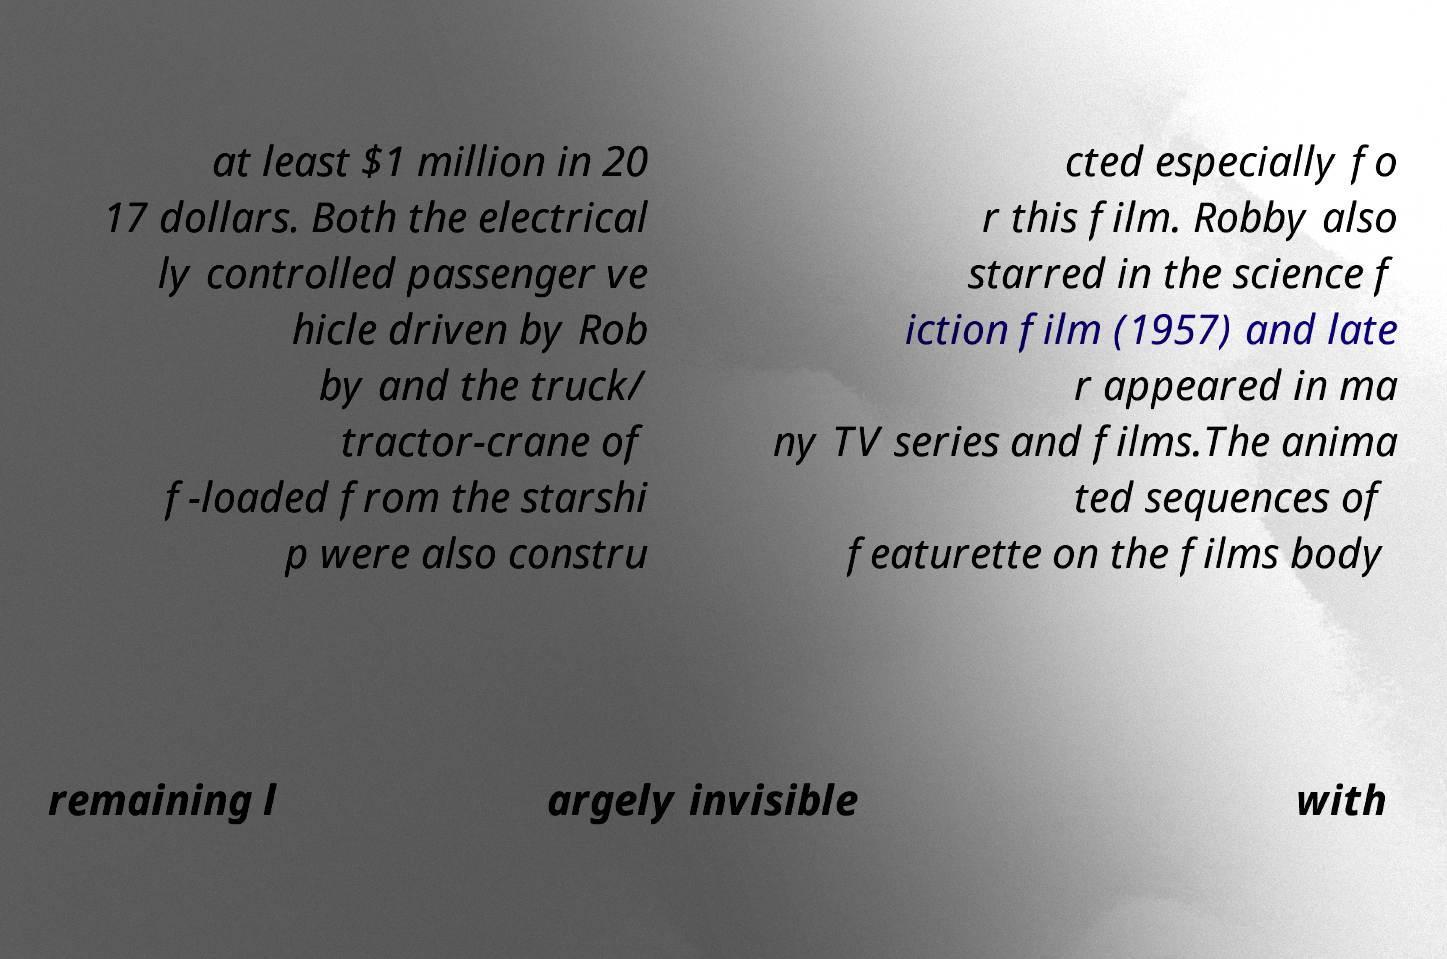Please read and relay the text visible in this image. What does it say? at least $1 million in 20 17 dollars. Both the electrical ly controlled passenger ve hicle driven by Rob by and the truck/ tractor-crane of f-loaded from the starshi p were also constru cted especially fo r this film. Robby also starred in the science f iction film (1957) and late r appeared in ma ny TV series and films.The anima ted sequences of featurette on the films body remaining l argely invisible with 